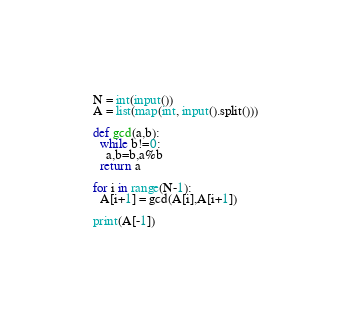<code> <loc_0><loc_0><loc_500><loc_500><_Python_>N = int(input())
A = list(map(int, input().split()))

def gcd(a,b):
  while b!=0:
    a,b=b,a%b
  return a

for i in range(N-1):
  A[i+1] = gcd(A[i],A[i+1])
  
print(A[-1])
  
</code> 